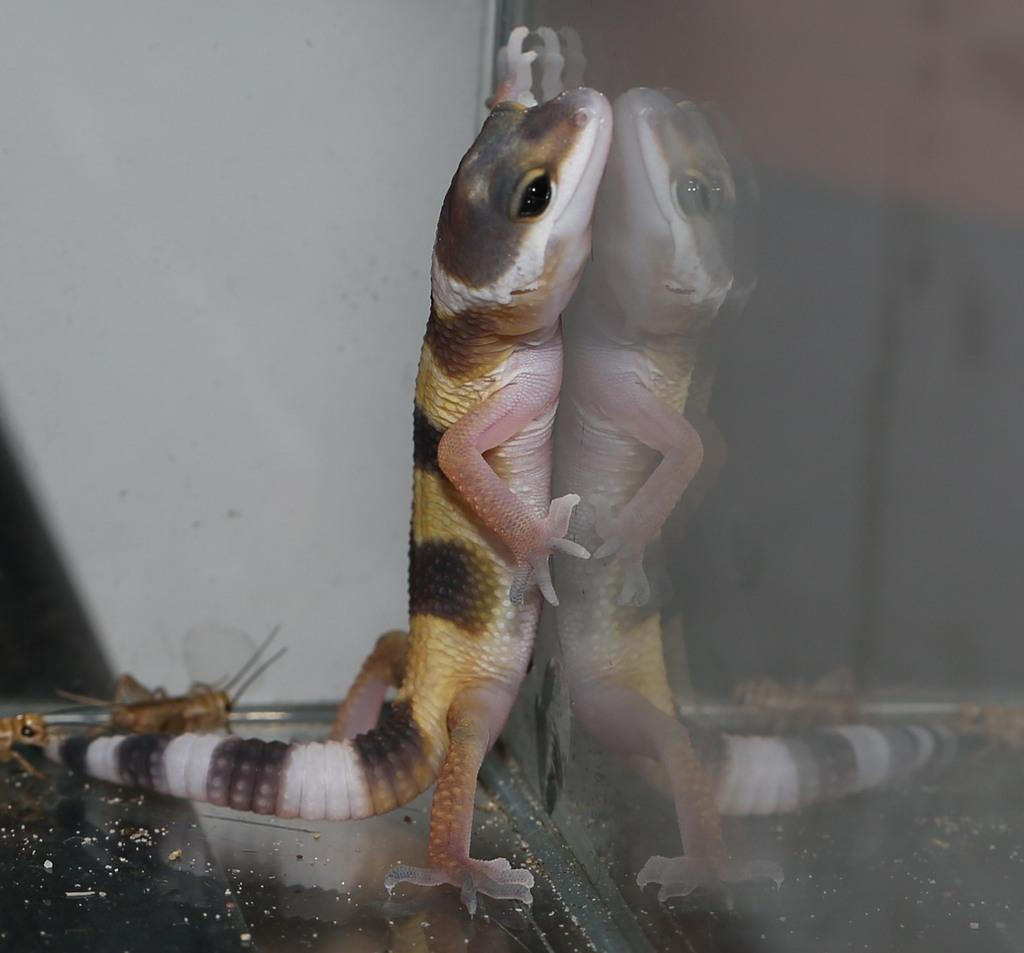What type of animal is on the glass surface in the image? There is a lizard on a glass surface in the image. What is the condition of the glass surface? The glass surface has dust on it. What can be seen in the background of the image? There is a white wall in the background. What type of apparel is the lizard wearing in the image? The lizard is not wearing any apparel in the image. What knowledge does the lizard possess about quantum physics in the image? The image does not provide any information about the lizard's knowledge of quantum physics. 